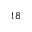<formula> <loc_0><loc_0><loc_500><loc_500>^ { 1 8 }</formula> 